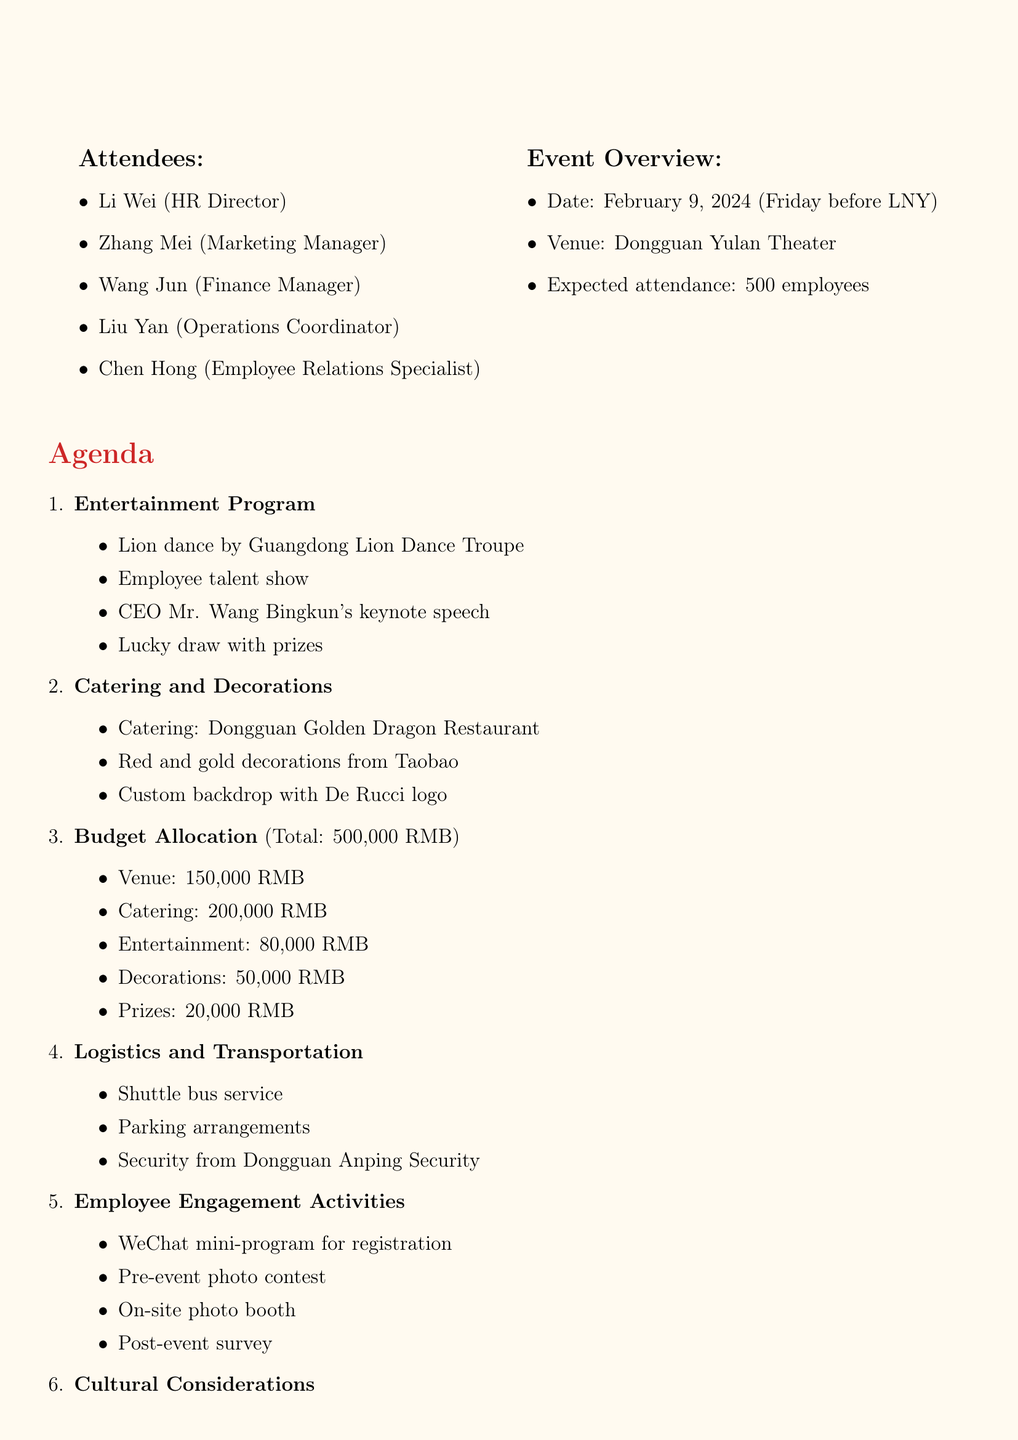What is the date of the event? The date of the event is provided in the document under Event Overview, specifically indicating when the celebration will take place.
Answer: February 9, 2024 Who is the HR Director? The document lists the attendees, including their titles, allowing for the identification of the HR Director.
Answer: Li Wei What is the total budget for the celebration? The budget allocation section explicitly states the total budget available for the event.
Answer: 500,000 RMB What entertainment will be featured? The Entertainment Program item details what kind of acts will be included in the event, describing the planned performances.
Answer: Traditional lion dance performance, employee talent show, keynote speech, lucky draw When must the venue booking be finalized? The timeline and responsibilities section outlines key deadlines, including when the venue reservation needs to be completed.
Answer: By December 20 How many employees are expected to attend? The expected attendance figure is given in the Event Overview, indicating how many employees are anticipated for the celebration.
Answer: 500 employees What kind of meal will be provided? The Catering and Decorations section identifies the type of cuisine to be offered during the event, focusing on the specific restaurant involved.
Answer: Traditional Cantonese cuisine What is included in the Employee Engagement Activities? The document specifies various activities designed to engage employees before and during the event, providing insights into employee involvement.
Answer: WeChat mini-program, photo contest, photo booth, satisfaction survey 